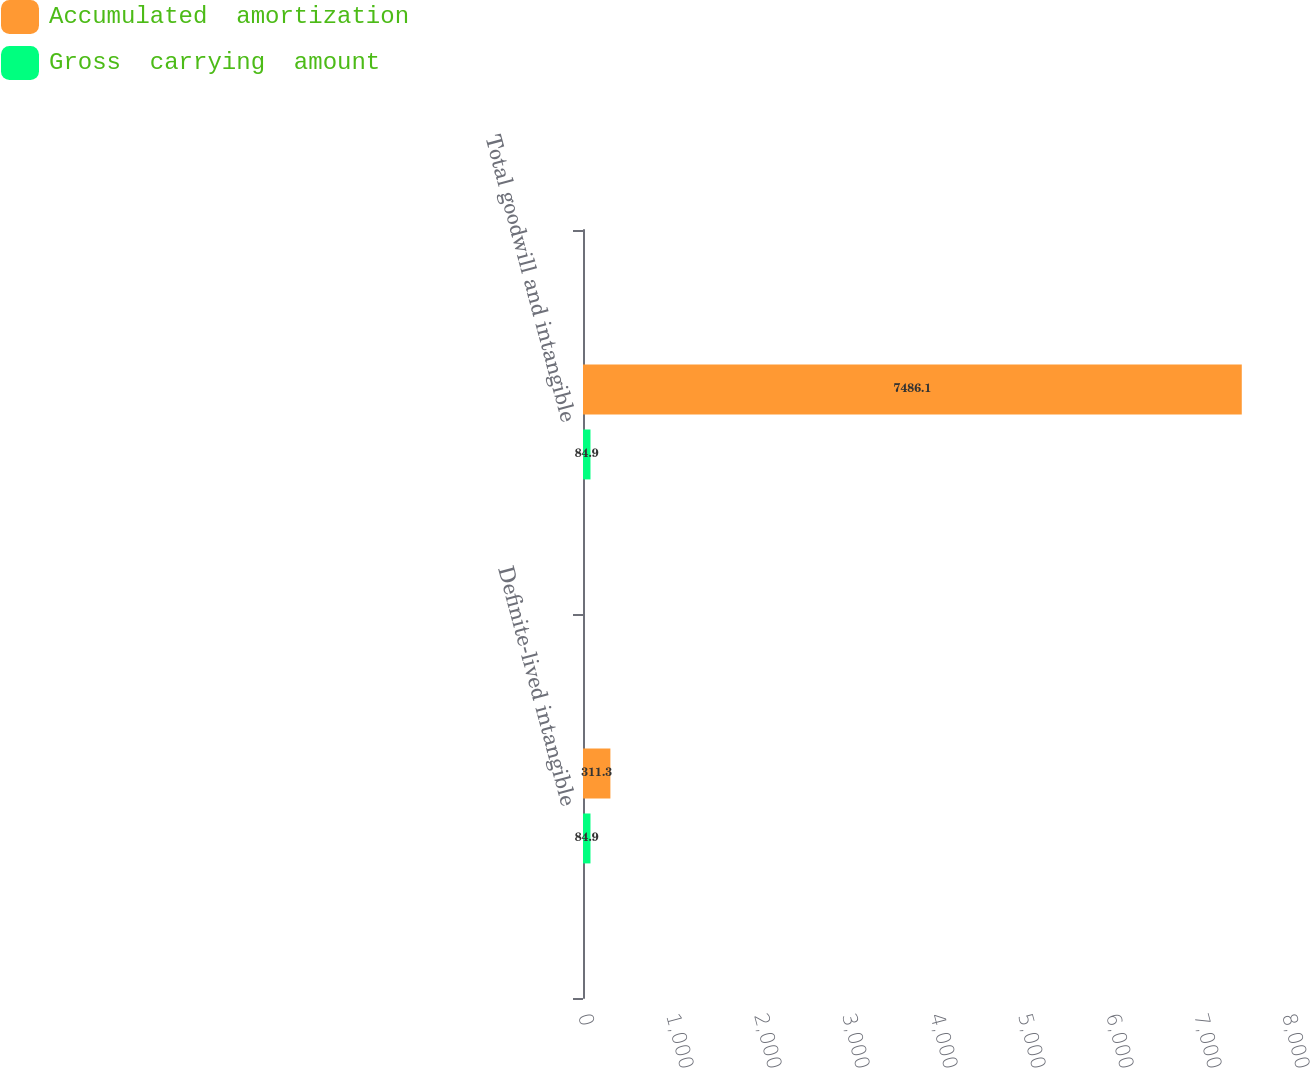<chart> <loc_0><loc_0><loc_500><loc_500><stacked_bar_chart><ecel><fcel>Definite-lived intangible<fcel>Total goodwill and intangible<nl><fcel>Accumulated  amortization<fcel>311.3<fcel>7486.1<nl><fcel>Gross  carrying  amount<fcel>84.9<fcel>84.9<nl></chart> 